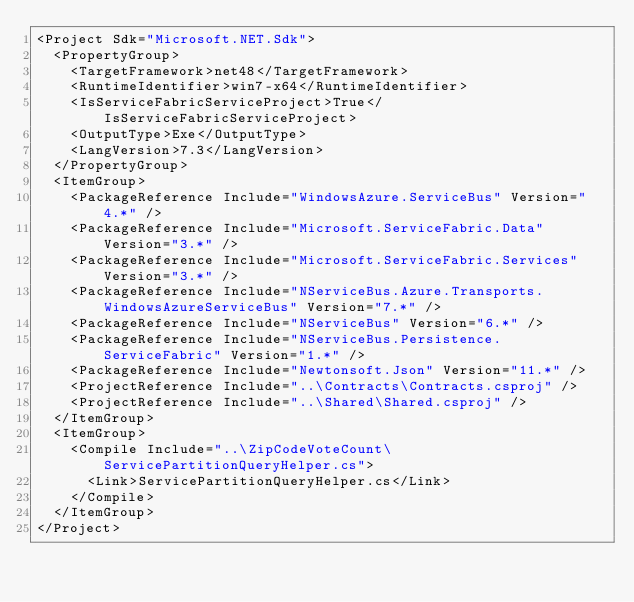Convert code to text. <code><loc_0><loc_0><loc_500><loc_500><_XML_><Project Sdk="Microsoft.NET.Sdk">
  <PropertyGroup>
    <TargetFramework>net48</TargetFramework>
    <RuntimeIdentifier>win7-x64</RuntimeIdentifier>
    <IsServiceFabricServiceProject>True</IsServiceFabricServiceProject>
    <OutputType>Exe</OutputType>
    <LangVersion>7.3</LangVersion>
  </PropertyGroup>
  <ItemGroup>
    <PackageReference Include="WindowsAzure.ServiceBus" Version="4.*" />
    <PackageReference Include="Microsoft.ServiceFabric.Data" Version="3.*" />
    <PackageReference Include="Microsoft.ServiceFabric.Services" Version="3.*" />
    <PackageReference Include="NServiceBus.Azure.Transports.WindowsAzureServiceBus" Version="7.*" />
    <PackageReference Include="NServiceBus" Version="6.*" />
    <PackageReference Include="NServiceBus.Persistence.ServiceFabric" Version="1.*" />
    <PackageReference Include="Newtonsoft.Json" Version="11.*" />
    <ProjectReference Include="..\Contracts\Contracts.csproj" />
    <ProjectReference Include="..\Shared\Shared.csproj" />
  </ItemGroup>
  <ItemGroup>
    <Compile Include="..\ZipCodeVoteCount\ServicePartitionQueryHelper.cs">
      <Link>ServicePartitionQueryHelper.cs</Link>
    </Compile>
  </ItemGroup>
</Project></code> 